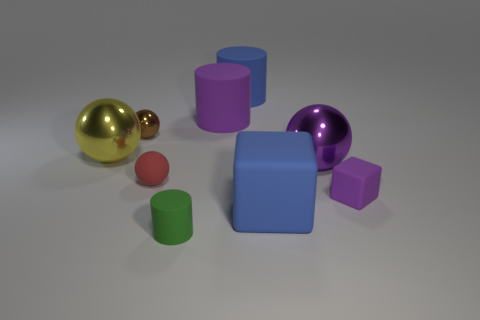Subtract all purple rubber cylinders. How many cylinders are left? 2 Subtract all brown spheres. How many spheres are left? 3 Subtract all balls. How many objects are left? 5 Subtract 1 blocks. How many blocks are left? 1 Subtract all brown balls. How many purple cubes are left? 1 Add 9 small cyan cubes. How many small cyan cubes exist? 9 Subtract 0 blue spheres. How many objects are left? 9 Subtract all purple balls. Subtract all green cubes. How many balls are left? 3 Subtract all purple cylinders. Subtract all large green metallic blocks. How many objects are left? 8 Add 1 cylinders. How many cylinders are left? 4 